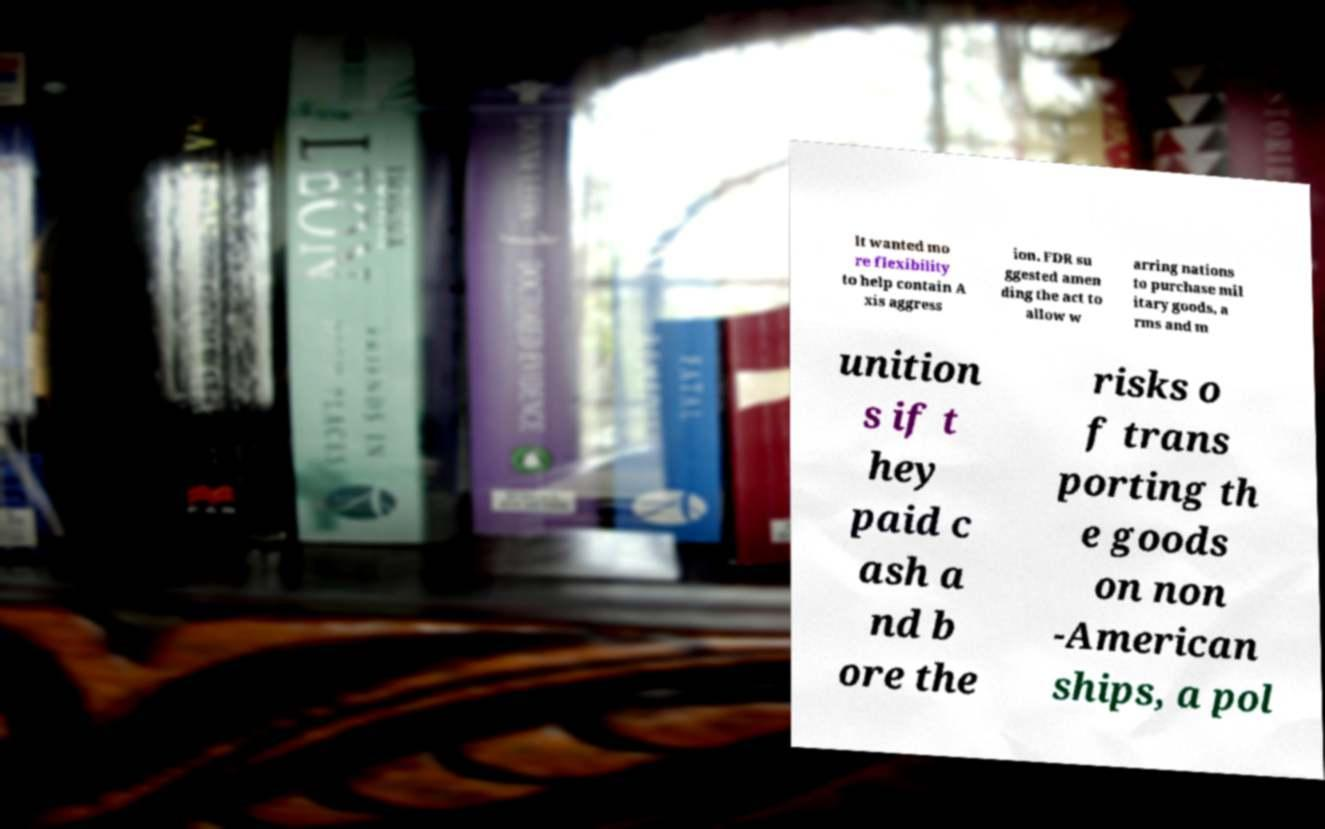I need the written content from this picture converted into text. Can you do that? lt wanted mo re flexibility to help contain A xis aggress ion. FDR su ggested amen ding the act to allow w arring nations to purchase mil itary goods, a rms and m unition s if t hey paid c ash a nd b ore the risks o f trans porting th e goods on non -American ships, a pol 